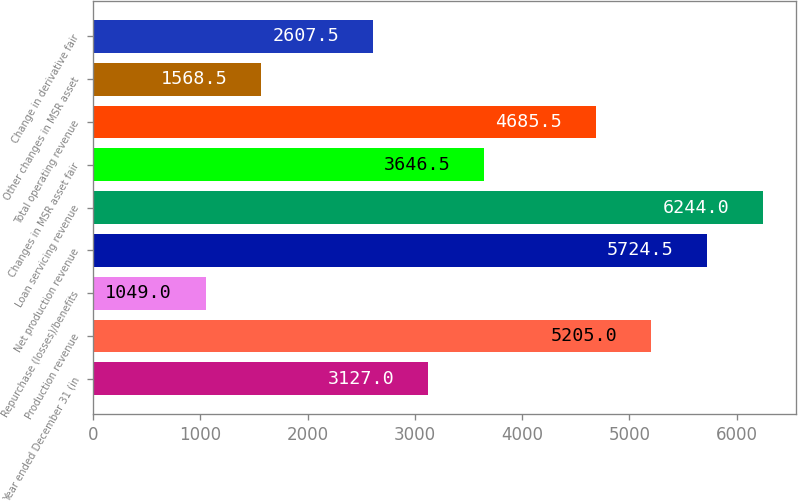Convert chart. <chart><loc_0><loc_0><loc_500><loc_500><bar_chart><fcel>Year ended December 31 (in<fcel>Production revenue<fcel>Repurchase (losses)/benefits<fcel>Net production revenue<fcel>Loan servicing revenue<fcel>Changes in MSR asset fair<fcel>Total operating revenue<fcel>Other changes in MSR asset<fcel>Change in derivative fair<nl><fcel>3127<fcel>5205<fcel>1049<fcel>5724.5<fcel>6244<fcel>3646.5<fcel>4685.5<fcel>1568.5<fcel>2607.5<nl></chart> 